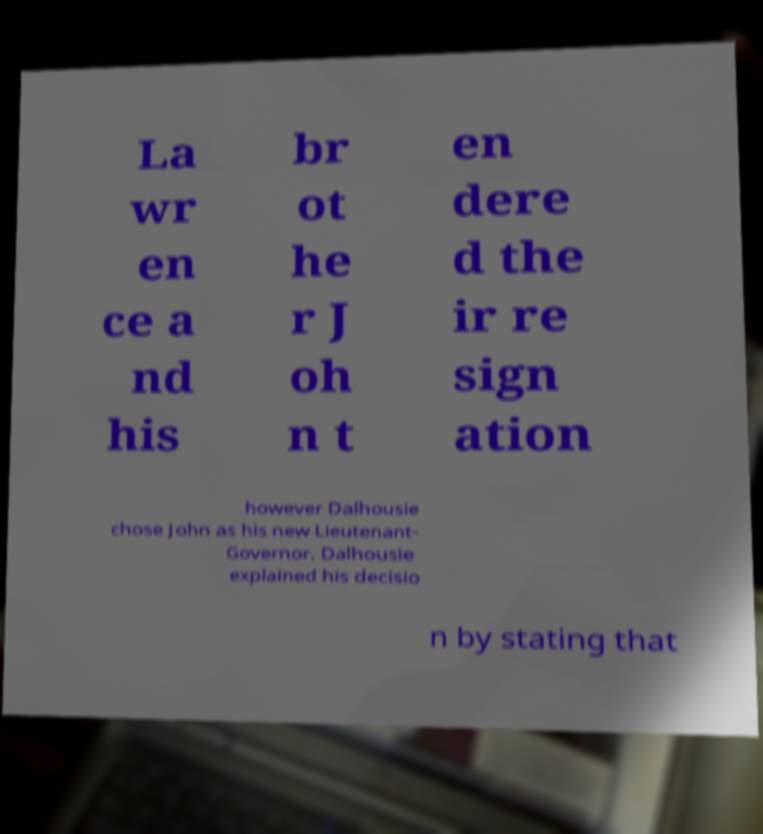Can you accurately transcribe the text from the provided image for me? La wr en ce a nd his br ot he r J oh n t en dere d the ir re sign ation however Dalhousie chose John as his new Lieutenant- Governor. Dalhousie explained his decisio n by stating that 